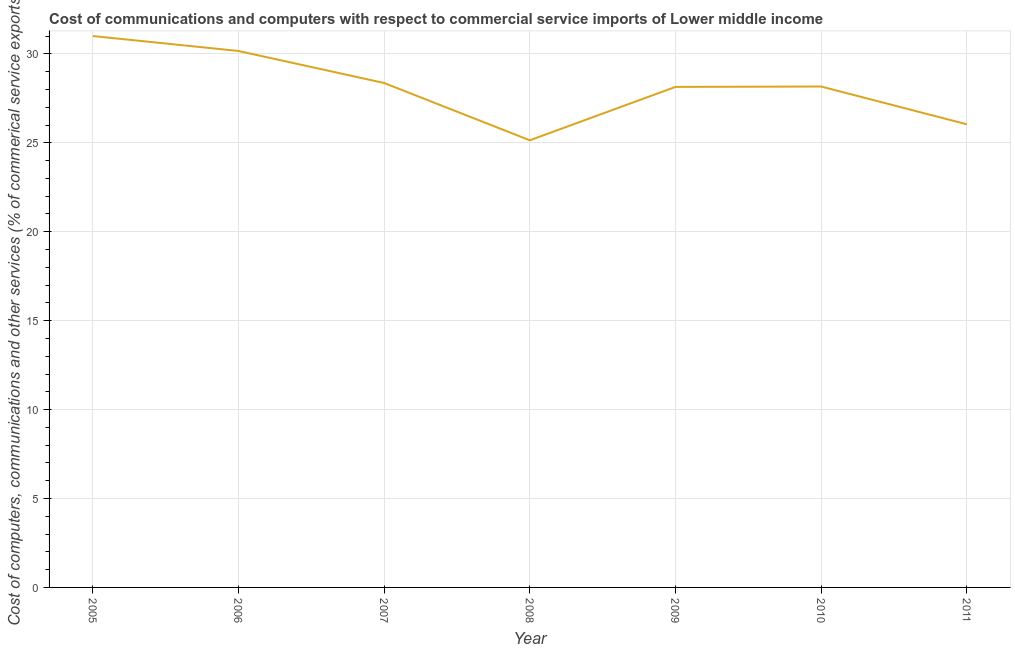What is the  computer and other services in 2008?
Offer a very short reply. 25.14. Across all years, what is the maximum  computer and other services?
Give a very brief answer. 31. Across all years, what is the minimum  computer and other services?
Your answer should be very brief. 25.14. In which year was the  computer and other services minimum?
Keep it short and to the point. 2008. What is the sum of the cost of communications?
Keep it short and to the point. 197.03. What is the difference between the  computer and other services in 2006 and 2011?
Offer a terse response. 4.12. What is the average cost of communications per year?
Provide a short and direct response. 28.15. What is the median  computer and other services?
Keep it short and to the point. 28.17. In how many years, is the cost of communications greater than 28 %?
Your response must be concise. 5. What is the ratio of the cost of communications in 2006 to that in 2007?
Your response must be concise. 1.06. Is the cost of communications in 2005 less than that in 2011?
Give a very brief answer. No. Is the difference between the cost of communications in 2006 and 2007 greater than the difference between any two years?
Offer a very short reply. No. What is the difference between the highest and the second highest cost of communications?
Offer a very short reply. 0.84. Is the sum of the  computer and other services in 2008 and 2010 greater than the maximum  computer and other services across all years?
Your answer should be very brief. Yes. What is the difference between the highest and the lowest  computer and other services?
Your response must be concise. 5.86. How many lines are there?
Provide a short and direct response. 1. What is the difference between two consecutive major ticks on the Y-axis?
Make the answer very short. 5. Are the values on the major ticks of Y-axis written in scientific E-notation?
Your answer should be very brief. No. Does the graph contain any zero values?
Offer a very short reply. No. Does the graph contain grids?
Provide a short and direct response. Yes. What is the title of the graph?
Ensure brevity in your answer.  Cost of communications and computers with respect to commercial service imports of Lower middle income. What is the label or title of the Y-axis?
Offer a very short reply. Cost of computers, communications and other services (% of commerical service exports). What is the Cost of computers, communications and other services (% of commerical service exports) in 2005?
Your response must be concise. 31. What is the Cost of computers, communications and other services (% of commerical service exports) of 2006?
Your answer should be very brief. 30.16. What is the Cost of computers, communications and other services (% of commerical service exports) of 2007?
Keep it short and to the point. 28.36. What is the Cost of computers, communications and other services (% of commerical service exports) in 2008?
Provide a short and direct response. 25.14. What is the Cost of computers, communications and other services (% of commerical service exports) of 2009?
Offer a terse response. 28.14. What is the Cost of computers, communications and other services (% of commerical service exports) of 2010?
Make the answer very short. 28.17. What is the Cost of computers, communications and other services (% of commerical service exports) in 2011?
Offer a terse response. 26.04. What is the difference between the Cost of computers, communications and other services (% of commerical service exports) in 2005 and 2006?
Ensure brevity in your answer.  0.84. What is the difference between the Cost of computers, communications and other services (% of commerical service exports) in 2005 and 2007?
Ensure brevity in your answer.  2.64. What is the difference between the Cost of computers, communications and other services (% of commerical service exports) in 2005 and 2008?
Your response must be concise. 5.86. What is the difference between the Cost of computers, communications and other services (% of commerical service exports) in 2005 and 2009?
Provide a succinct answer. 2.86. What is the difference between the Cost of computers, communications and other services (% of commerical service exports) in 2005 and 2010?
Your answer should be very brief. 2.84. What is the difference between the Cost of computers, communications and other services (% of commerical service exports) in 2005 and 2011?
Your answer should be compact. 4.96. What is the difference between the Cost of computers, communications and other services (% of commerical service exports) in 2006 and 2007?
Provide a short and direct response. 1.8. What is the difference between the Cost of computers, communications and other services (% of commerical service exports) in 2006 and 2008?
Your answer should be compact. 5.02. What is the difference between the Cost of computers, communications and other services (% of commerical service exports) in 2006 and 2009?
Ensure brevity in your answer.  2.02. What is the difference between the Cost of computers, communications and other services (% of commerical service exports) in 2006 and 2010?
Offer a very short reply. 2. What is the difference between the Cost of computers, communications and other services (% of commerical service exports) in 2006 and 2011?
Your answer should be very brief. 4.12. What is the difference between the Cost of computers, communications and other services (% of commerical service exports) in 2007 and 2008?
Provide a succinct answer. 3.22. What is the difference between the Cost of computers, communications and other services (% of commerical service exports) in 2007 and 2009?
Offer a terse response. 0.22. What is the difference between the Cost of computers, communications and other services (% of commerical service exports) in 2007 and 2010?
Give a very brief answer. 0.2. What is the difference between the Cost of computers, communications and other services (% of commerical service exports) in 2007 and 2011?
Your answer should be compact. 2.32. What is the difference between the Cost of computers, communications and other services (% of commerical service exports) in 2008 and 2009?
Ensure brevity in your answer.  -3. What is the difference between the Cost of computers, communications and other services (% of commerical service exports) in 2008 and 2010?
Your answer should be very brief. -3.02. What is the difference between the Cost of computers, communications and other services (% of commerical service exports) in 2008 and 2011?
Offer a terse response. -0.9. What is the difference between the Cost of computers, communications and other services (% of commerical service exports) in 2009 and 2010?
Offer a terse response. -0.02. What is the difference between the Cost of computers, communications and other services (% of commerical service exports) in 2009 and 2011?
Keep it short and to the point. 2.1. What is the difference between the Cost of computers, communications and other services (% of commerical service exports) in 2010 and 2011?
Provide a short and direct response. 2.12. What is the ratio of the Cost of computers, communications and other services (% of commerical service exports) in 2005 to that in 2006?
Your answer should be very brief. 1.03. What is the ratio of the Cost of computers, communications and other services (% of commerical service exports) in 2005 to that in 2007?
Keep it short and to the point. 1.09. What is the ratio of the Cost of computers, communications and other services (% of commerical service exports) in 2005 to that in 2008?
Give a very brief answer. 1.23. What is the ratio of the Cost of computers, communications and other services (% of commerical service exports) in 2005 to that in 2009?
Provide a succinct answer. 1.1. What is the ratio of the Cost of computers, communications and other services (% of commerical service exports) in 2005 to that in 2010?
Ensure brevity in your answer.  1.1. What is the ratio of the Cost of computers, communications and other services (% of commerical service exports) in 2005 to that in 2011?
Offer a terse response. 1.19. What is the ratio of the Cost of computers, communications and other services (% of commerical service exports) in 2006 to that in 2007?
Give a very brief answer. 1.06. What is the ratio of the Cost of computers, communications and other services (% of commerical service exports) in 2006 to that in 2008?
Keep it short and to the point. 1.2. What is the ratio of the Cost of computers, communications and other services (% of commerical service exports) in 2006 to that in 2009?
Your response must be concise. 1.07. What is the ratio of the Cost of computers, communications and other services (% of commerical service exports) in 2006 to that in 2010?
Offer a very short reply. 1.07. What is the ratio of the Cost of computers, communications and other services (% of commerical service exports) in 2006 to that in 2011?
Provide a short and direct response. 1.16. What is the ratio of the Cost of computers, communications and other services (% of commerical service exports) in 2007 to that in 2008?
Your answer should be compact. 1.13. What is the ratio of the Cost of computers, communications and other services (% of commerical service exports) in 2007 to that in 2011?
Offer a very short reply. 1.09. What is the ratio of the Cost of computers, communications and other services (% of commerical service exports) in 2008 to that in 2009?
Provide a short and direct response. 0.89. What is the ratio of the Cost of computers, communications and other services (% of commerical service exports) in 2008 to that in 2010?
Give a very brief answer. 0.89. What is the ratio of the Cost of computers, communications and other services (% of commerical service exports) in 2009 to that in 2010?
Provide a succinct answer. 1. What is the ratio of the Cost of computers, communications and other services (% of commerical service exports) in 2009 to that in 2011?
Offer a very short reply. 1.08. What is the ratio of the Cost of computers, communications and other services (% of commerical service exports) in 2010 to that in 2011?
Ensure brevity in your answer.  1.08. 